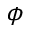Convert formula to latex. <formula><loc_0><loc_0><loc_500><loc_500>\phi</formula> 